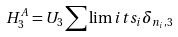<formula> <loc_0><loc_0><loc_500><loc_500>H ^ { A } _ { 3 } = U _ { 3 } \sum \lim i t s _ { i } \delta _ { n _ { i } , 3 }</formula> 